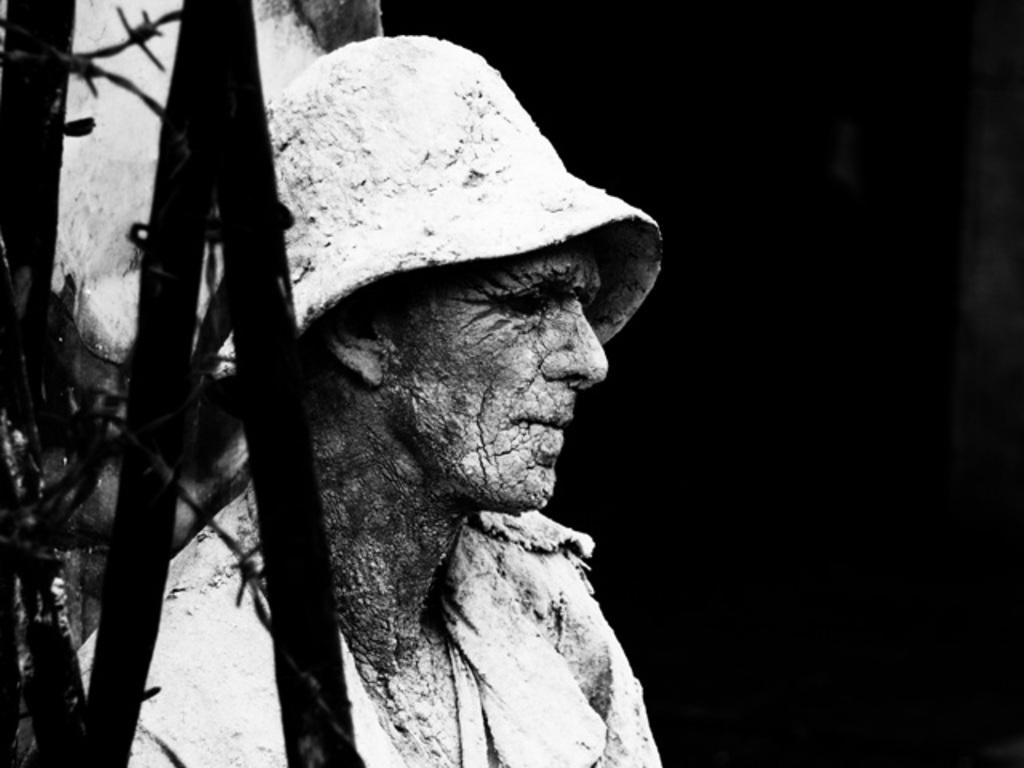What is the main subject in the image? There is a statue in the image. What else can be seen in the image besides the statue? There is a fence in the image. Where can the bread be found in the image? There is no bread present in the image. What type of animals can be seen at the zoo in the image? There is no zoo present in the image. 